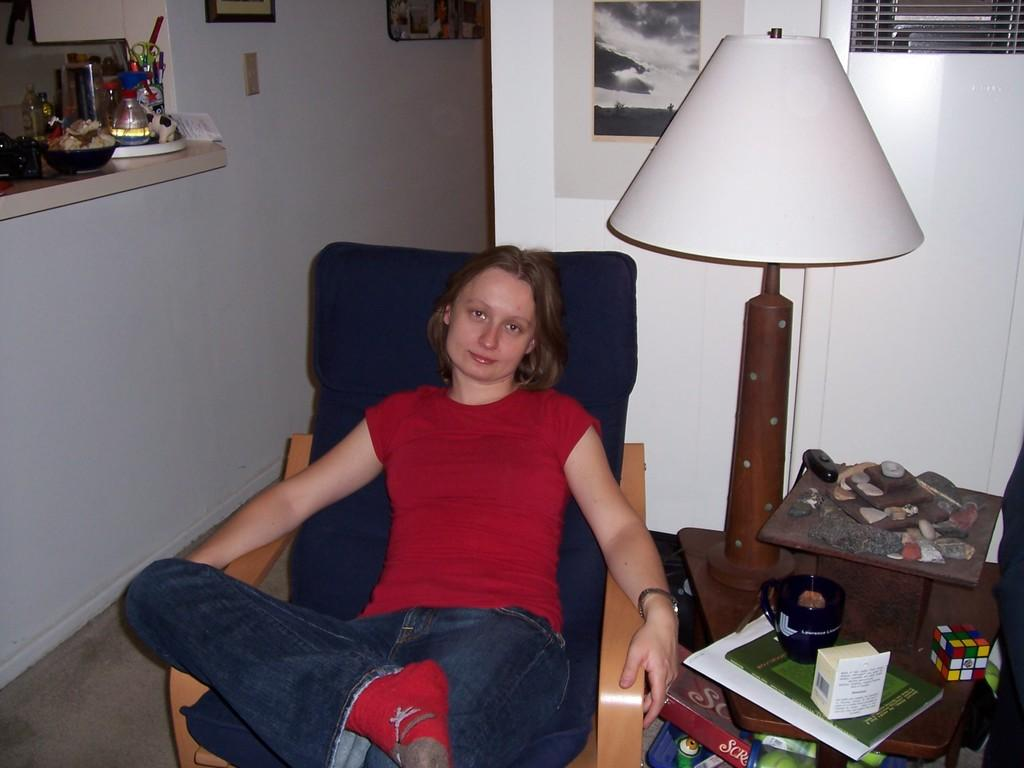Who is present in the image? There is a woman in the image. What can be seen in the background of the image? There is a light in the image. What is on the table in the image? There are papers and a toy on the table in the image. How many cherries are on the table in the image? There are no cherries present in the image. What question is the woman asking in the image? There is no indication of a question being asked in the image. 